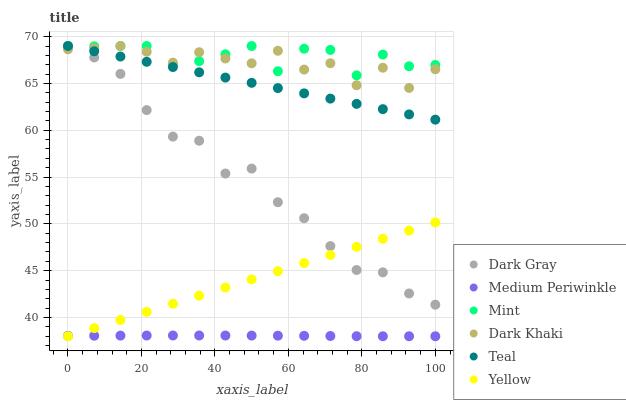Does Medium Periwinkle have the minimum area under the curve?
Answer yes or no. Yes. Does Mint have the maximum area under the curve?
Answer yes or no. Yes. Does Yellow have the minimum area under the curve?
Answer yes or no. No. Does Yellow have the maximum area under the curve?
Answer yes or no. No. Is Yellow the smoothest?
Answer yes or no. Yes. Is Dark Khaki the roughest?
Answer yes or no. Yes. Is Medium Periwinkle the smoothest?
Answer yes or no. No. Is Medium Periwinkle the roughest?
Answer yes or no. No. Does Medium Periwinkle have the lowest value?
Answer yes or no. Yes. Does Dark Gray have the lowest value?
Answer yes or no. No. Does Mint have the highest value?
Answer yes or no. Yes. Does Yellow have the highest value?
Answer yes or no. No. Is Yellow less than Mint?
Answer yes or no. Yes. Is Teal greater than Yellow?
Answer yes or no. Yes. Does Dark Khaki intersect Dark Gray?
Answer yes or no. Yes. Is Dark Khaki less than Dark Gray?
Answer yes or no. No. Is Dark Khaki greater than Dark Gray?
Answer yes or no. No. Does Yellow intersect Mint?
Answer yes or no. No. 